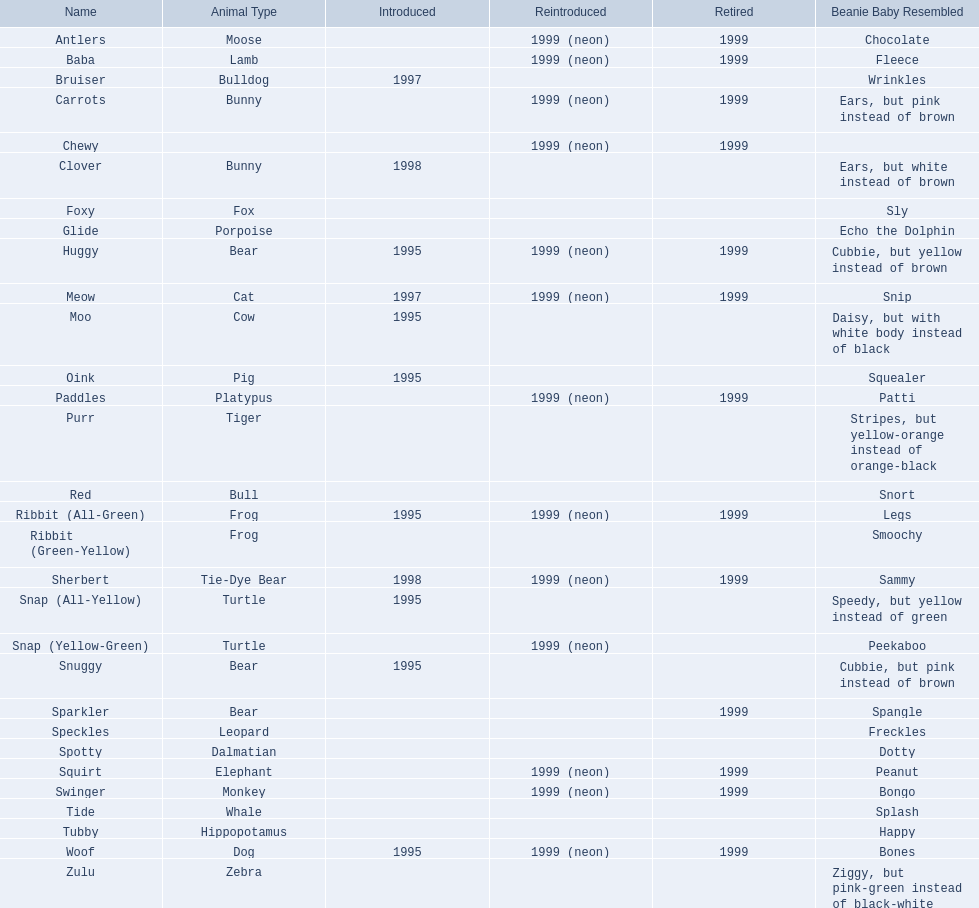What are the mentioned names? Antlers, Baba, Bruiser, Carrots, Chewy, Clover, Foxy, Glide, Huggy, Meow, Moo, Oink, Paddles, Purr, Red, Ribbit (All-Green), Ribbit (Green-Yellow), Sherbert, Snap (All-Yellow), Snap (Yellow-Green), Snuggy, Sparkler, Speckles, Spotty, Squirt, Swinger, Tide, Tubby, Woof, Zulu. Among them, which is the only pet without a specified animal category? Chewy. 